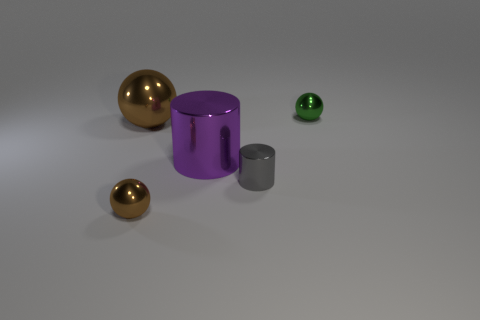What is the size of the ball that is on the right side of the brown shiny thing in front of the small gray object?
Ensure brevity in your answer.  Small. There is a large shiny thing behind the large purple thing; is its color the same as the tiny metallic thing in front of the gray shiny thing?
Give a very brief answer. Yes. There is a green ball; how many large metallic cylinders are to the right of it?
Make the answer very short. 0. Are there any other metal objects of the same shape as the green object?
Your response must be concise. Yes. Is the small object that is on the left side of the large purple thing made of the same material as the tiny sphere behind the big brown thing?
Offer a terse response. Yes. There is a sphere that is in front of the brown metallic ball on the left side of the small object to the left of the large cylinder; what is its size?
Provide a short and direct response. Small. There is a brown sphere that is the same size as the gray metallic object; what material is it?
Offer a very short reply. Metal. Are there any green shiny things of the same size as the gray thing?
Make the answer very short. Yes. Is the shape of the small gray thing the same as the big purple object?
Make the answer very short. Yes. Are there any big brown shiny balls behind the green object that is on the right side of the brown ball that is behind the purple cylinder?
Your answer should be compact. No. 